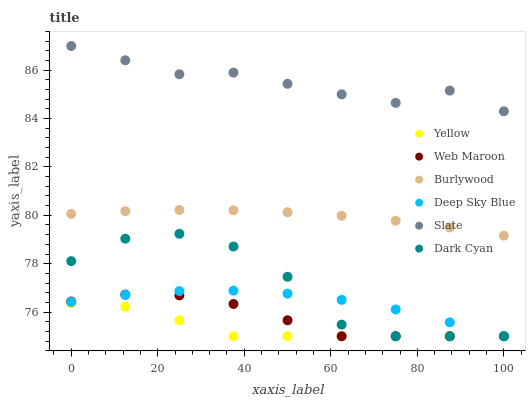Does Yellow have the minimum area under the curve?
Answer yes or no. Yes. Does Slate have the maximum area under the curve?
Answer yes or no. Yes. Does Web Maroon have the minimum area under the curve?
Answer yes or no. No. Does Web Maroon have the maximum area under the curve?
Answer yes or no. No. Is Burlywood the smoothest?
Answer yes or no. Yes. Is Dark Cyan the roughest?
Answer yes or no. Yes. Is Slate the smoothest?
Answer yes or no. No. Is Slate the roughest?
Answer yes or no. No. Does Web Maroon have the lowest value?
Answer yes or no. Yes. Does Slate have the lowest value?
Answer yes or no. No. Does Slate have the highest value?
Answer yes or no. Yes. Does Web Maroon have the highest value?
Answer yes or no. No. Is Deep Sky Blue less than Burlywood?
Answer yes or no. Yes. Is Slate greater than Yellow?
Answer yes or no. Yes. Does Yellow intersect Dark Cyan?
Answer yes or no. Yes. Is Yellow less than Dark Cyan?
Answer yes or no. No. Is Yellow greater than Dark Cyan?
Answer yes or no. No. Does Deep Sky Blue intersect Burlywood?
Answer yes or no. No. 